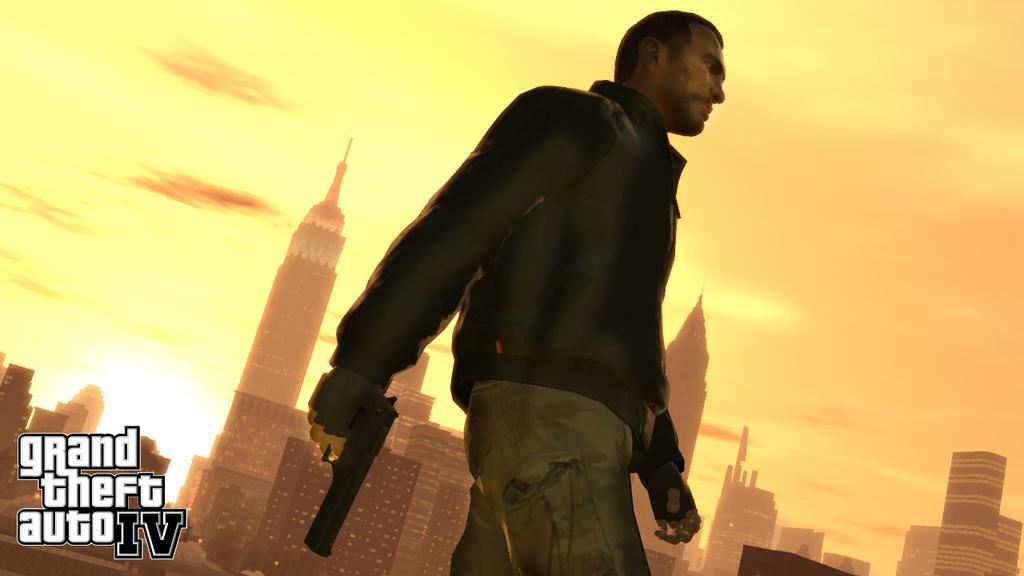Describe this image in one or two sentences. In this image I can see the depiction picture. In that picture I can see a man is standing in the front and I can see he is holding a gun. In the background I can see number of buildings, clouds and the sky. On the bottom left side of the image I can see something is written. 